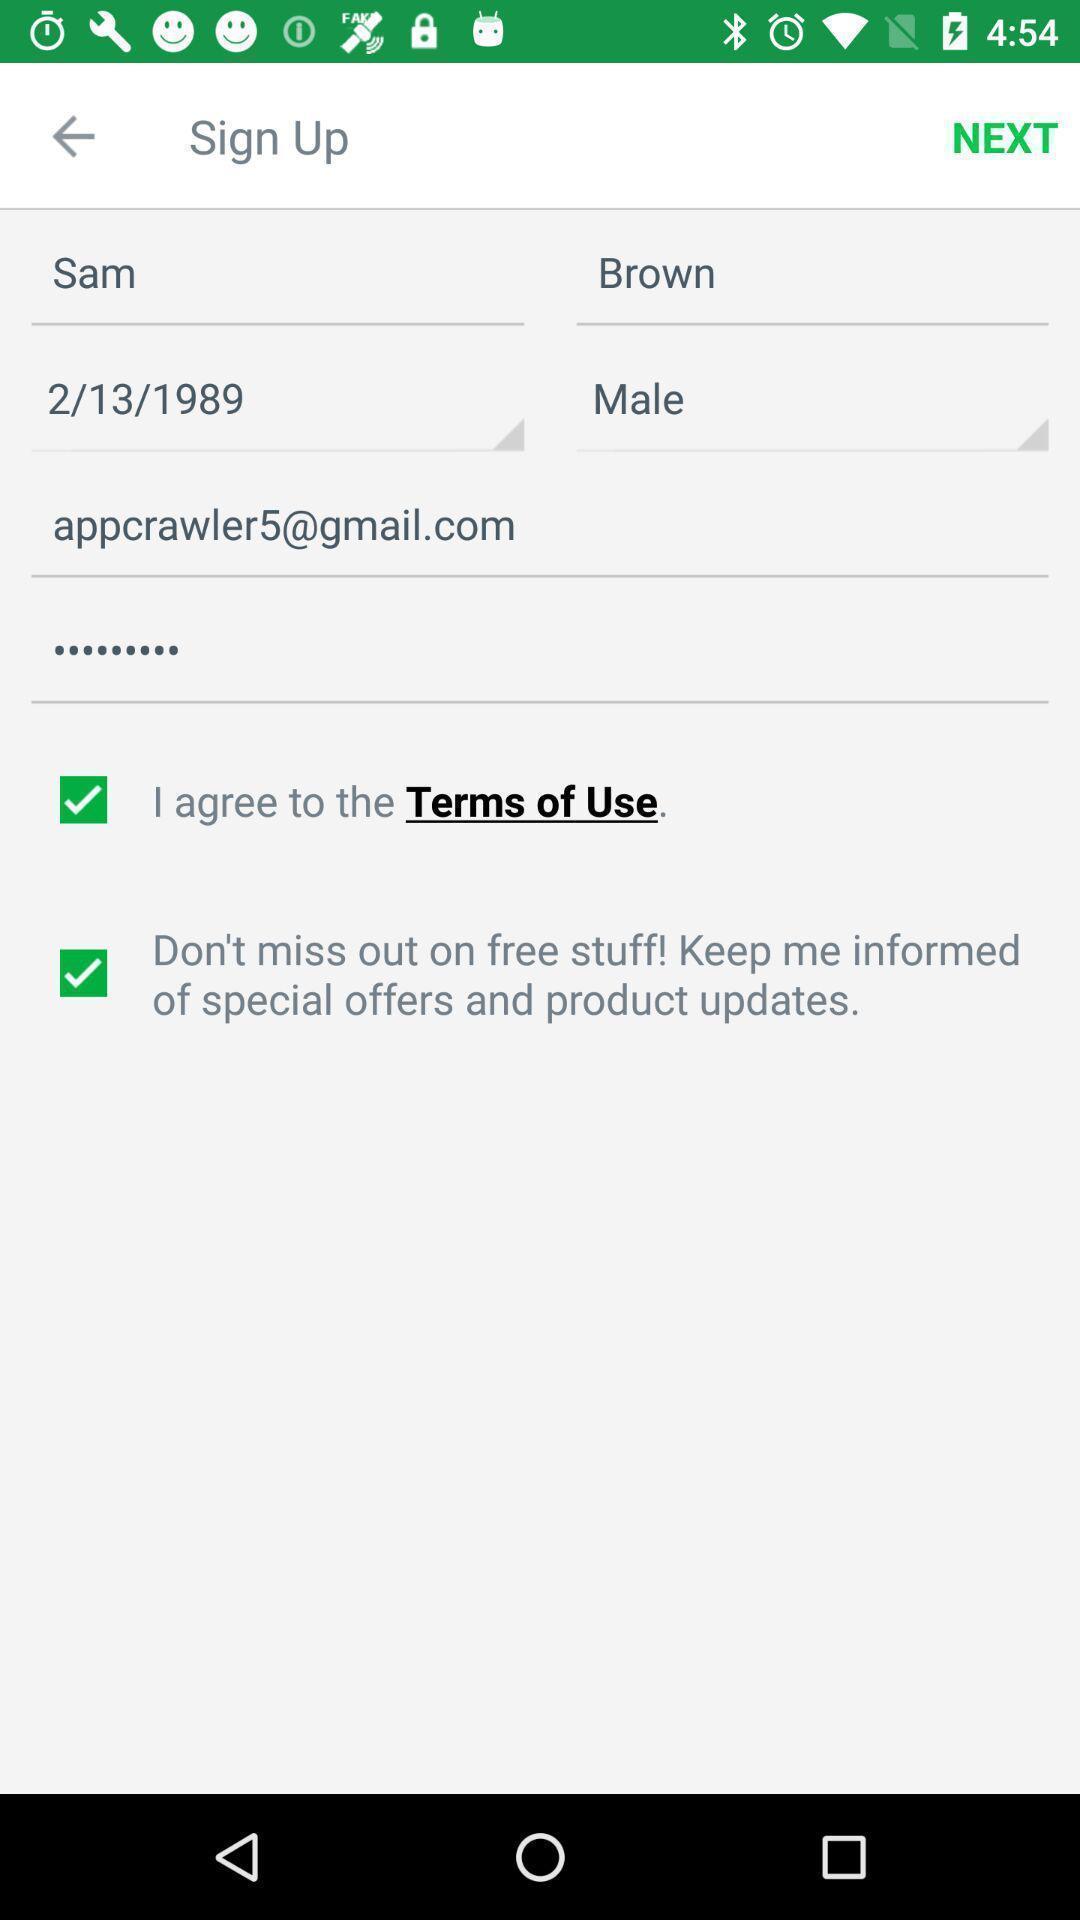Give me a narrative description of this picture. Sign up page. 